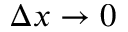<formula> <loc_0><loc_0><loc_500><loc_500>\Delta x \rightarrow 0</formula> 